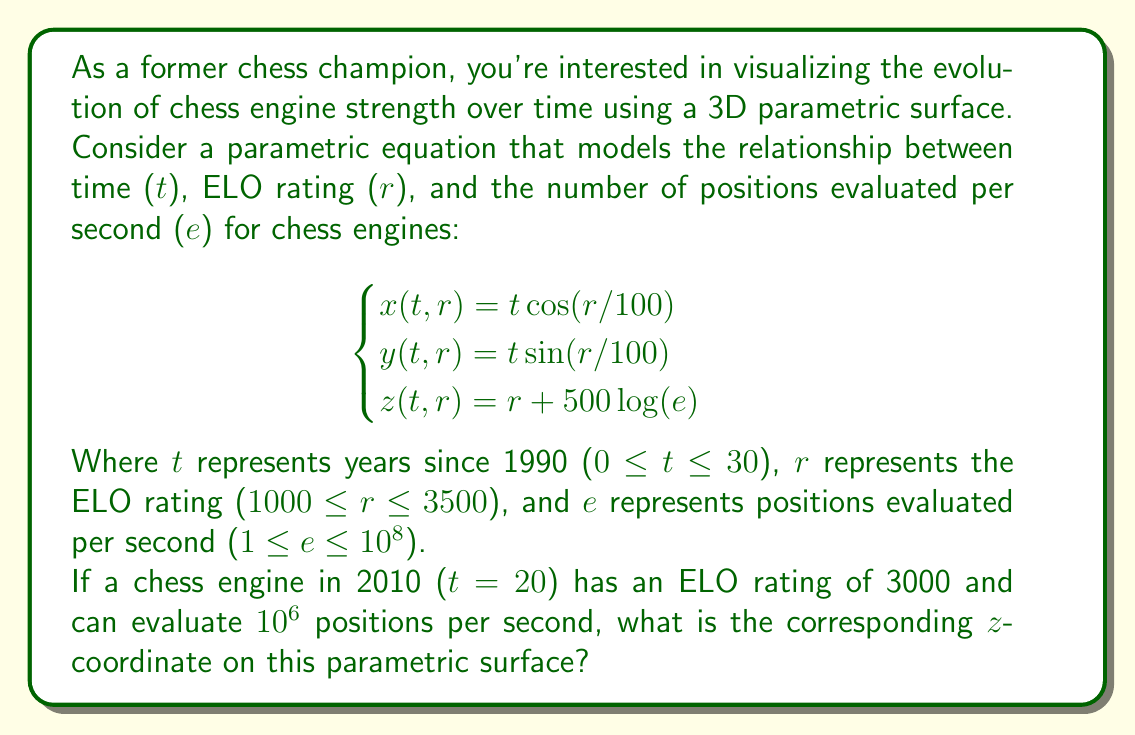Show me your answer to this math problem. To solve this problem, we need to use the given parametric equation for the z-coordinate and plug in the appropriate values. Let's break it down step by step:

1. The z-coordinate equation is given as:
   $$z(t,r) = r + 500 \log(e)$$

2. We're given the following information:
   - Year: 2010, which corresponds to t = 20 (but we don't need this for z)
   - ELO rating: r = 3000
   - Positions evaluated per second: e = 10^6

3. Let's substitute these values into the equation:
   $$z = 3000 + 500 \log(10^6)$$

4. Now, we need to calculate $\log(10^6)$:
   $$\log(10^6) = \log(1,000,000) = 6$$
   (Note: We assume this is a natural logarithm, as it's not specified otherwise)

5. Substituting this back into our equation:
   $$z = 3000 + 500 * 6$$

6. Simplifying:
   $$z = 3000 + 3000 = 6000$$

Therefore, the z-coordinate for this chess engine on the parametric surface is 6000.
Answer: 6000 